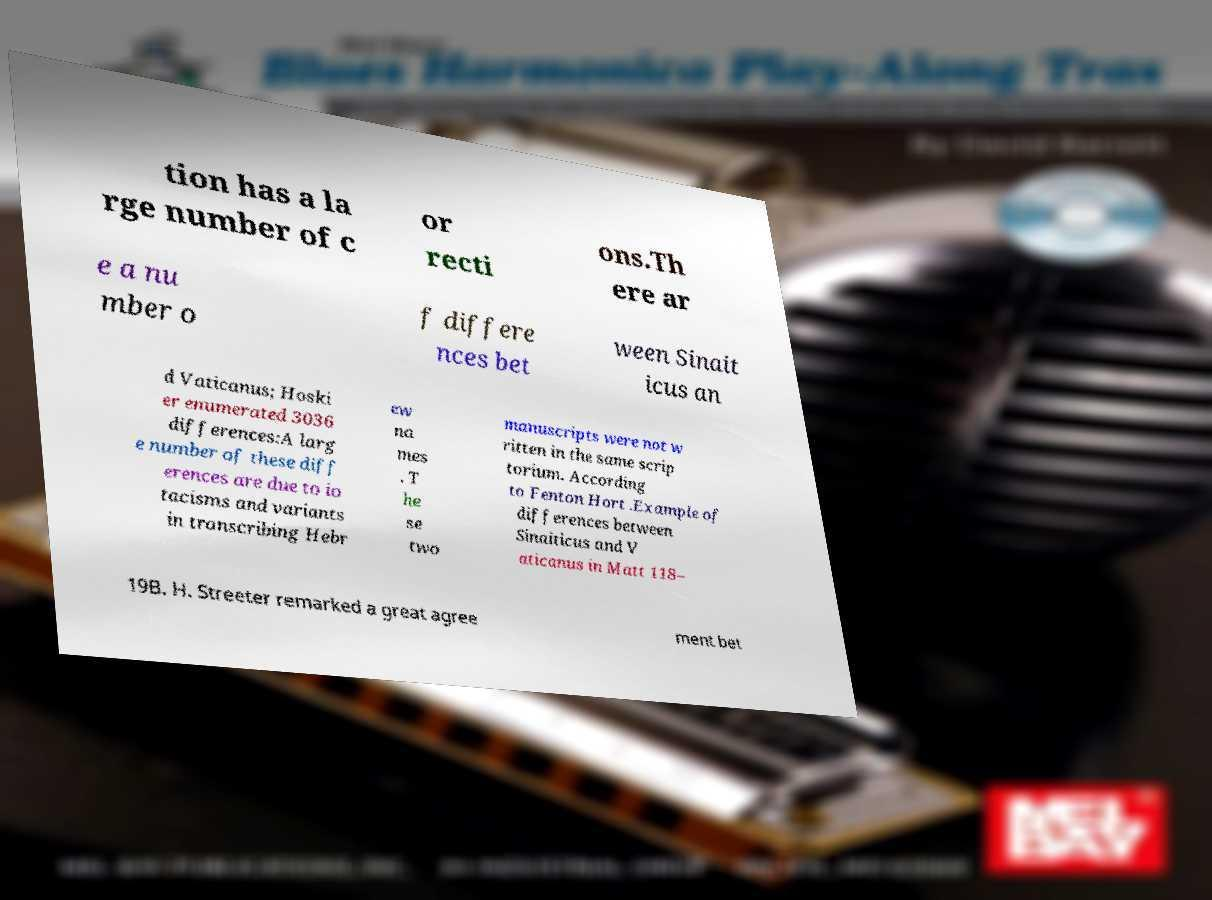For documentation purposes, I need the text within this image transcribed. Could you provide that? tion has a la rge number of c or recti ons.Th ere ar e a nu mber o f differe nces bet ween Sinait icus an d Vaticanus; Hoski er enumerated 3036 differences:A larg e number of these diff erences are due to io tacisms and variants in transcribing Hebr ew na mes . T he se two manuscripts were not w ritten in the same scrip torium. According to Fenton Hort .Example of differences between Sinaiticus and V aticanus in Matt 118– 19B. H. Streeter remarked a great agree ment bet 